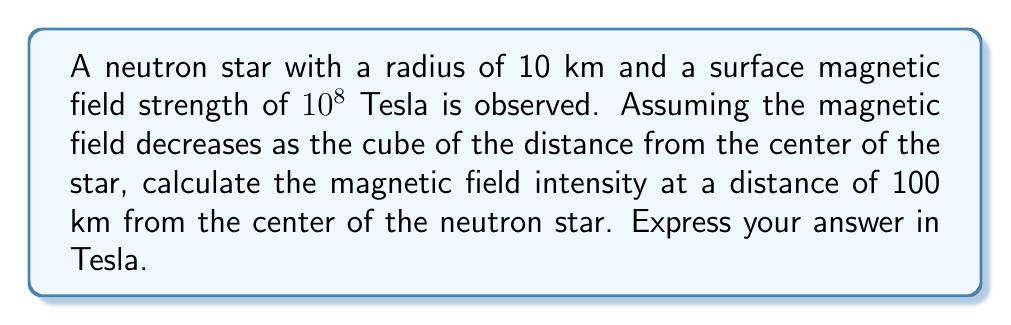Give your solution to this math problem. Let's approach this step-by-step:

1) The magnetic field of a neutron star can be approximated as a dipole field, which decreases with the cube of the distance from the center of the star. We can express this as:

   $$B(r) = B_s \left(\frac{R}{r}\right)^3$$

   Where:
   $B(r)$ is the magnetic field at distance $r$
   $B_s$ is the surface magnetic field strength
   $R$ is the radius of the neutron star
   $r$ is the distance from the center of the star

2) We are given:
   $B_s = 10^8$ Tesla
   $R = 10$ km
   $r = 100$ km

3) Let's substitute these values into our equation:

   $$B(100) = 10^8 \left(\frac{10}{100}\right)^3$$

4) Simplify the fraction inside the parentheses:

   $$B(100) = 10^8 \left(\frac{1}{10}\right)^3$$

5) Calculate the cube:

   $$B(100) = 10^8 \cdot \frac{1}{1000}$$

6) Simplify:

   $$B(100) = 10^5$$ Tesla

Therefore, the magnetic field intensity at a distance of 100 km from the center of the neutron star is $10^5$ Tesla.
Answer: $10^5$ Tesla 